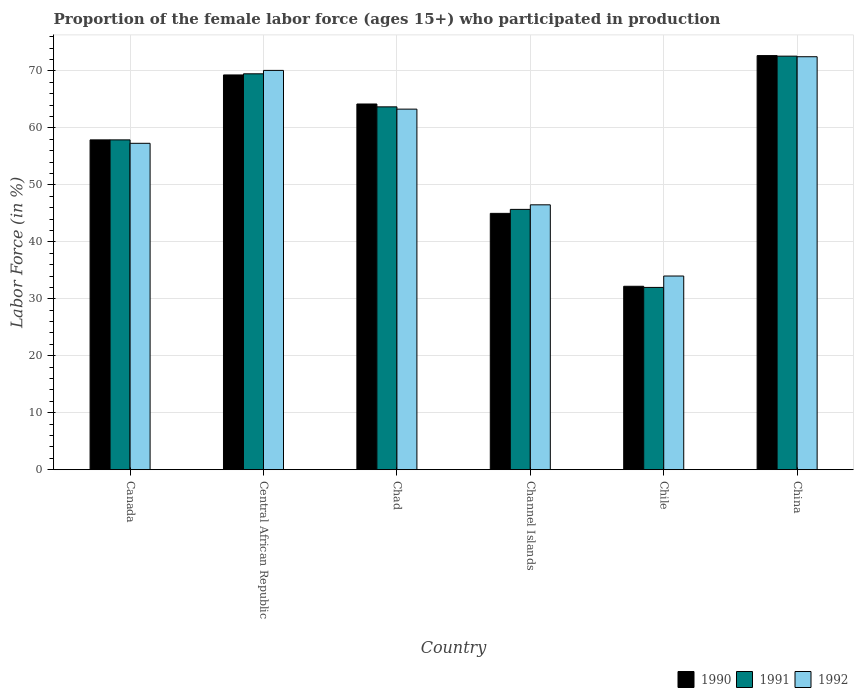How many groups of bars are there?
Ensure brevity in your answer.  6. Are the number of bars per tick equal to the number of legend labels?
Your response must be concise. Yes. Are the number of bars on each tick of the X-axis equal?
Your answer should be very brief. Yes. How many bars are there on the 5th tick from the left?
Offer a very short reply. 3. How many bars are there on the 3rd tick from the right?
Provide a succinct answer. 3. In how many cases, is the number of bars for a given country not equal to the number of legend labels?
Give a very brief answer. 0. What is the proportion of the female labor force who participated in production in 1992 in Channel Islands?
Provide a succinct answer. 46.5. Across all countries, what is the maximum proportion of the female labor force who participated in production in 1992?
Your answer should be compact. 72.5. Across all countries, what is the minimum proportion of the female labor force who participated in production in 1990?
Give a very brief answer. 32.2. In which country was the proportion of the female labor force who participated in production in 1990 maximum?
Offer a very short reply. China. In which country was the proportion of the female labor force who participated in production in 1990 minimum?
Your response must be concise. Chile. What is the total proportion of the female labor force who participated in production in 1992 in the graph?
Provide a succinct answer. 343.7. What is the difference between the proportion of the female labor force who participated in production in 1992 in Canada and that in Chad?
Offer a very short reply. -6. What is the difference between the proportion of the female labor force who participated in production in 1990 in Canada and the proportion of the female labor force who participated in production in 1991 in Channel Islands?
Make the answer very short. 12.2. What is the average proportion of the female labor force who participated in production in 1992 per country?
Provide a short and direct response. 57.28. What is the difference between the proportion of the female labor force who participated in production of/in 1991 and proportion of the female labor force who participated in production of/in 1992 in Channel Islands?
Offer a terse response. -0.8. What is the ratio of the proportion of the female labor force who participated in production in 1992 in Canada to that in Chad?
Your response must be concise. 0.91. Is the proportion of the female labor force who participated in production in 1990 in Central African Republic less than that in China?
Make the answer very short. Yes. Is the difference between the proportion of the female labor force who participated in production in 1991 in Channel Islands and Chile greater than the difference between the proportion of the female labor force who participated in production in 1992 in Channel Islands and Chile?
Your answer should be compact. Yes. What is the difference between the highest and the second highest proportion of the female labor force who participated in production in 1992?
Make the answer very short. 2.4. What is the difference between the highest and the lowest proportion of the female labor force who participated in production in 1992?
Provide a succinct answer. 38.5. What does the 1st bar from the left in Chad represents?
Your answer should be compact. 1990. Are all the bars in the graph horizontal?
Make the answer very short. No. How many countries are there in the graph?
Give a very brief answer. 6. Does the graph contain grids?
Offer a very short reply. Yes. Where does the legend appear in the graph?
Offer a terse response. Bottom right. How are the legend labels stacked?
Offer a terse response. Horizontal. What is the title of the graph?
Your answer should be compact. Proportion of the female labor force (ages 15+) who participated in production. Does "1982" appear as one of the legend labels in the graph?
Your answer should be very brief. No. What is the label or title of the X-axis?
Your answer should be very brief. Country. What is the label or title of the Y-axis?
Make the answer very short. Labor Force (in %). What is the Labor Force (in %) of 1990 in Canada?
Make the answer very short. 57.9. What is the Labor Force (in %) of 1991 in Canada?
Give a very brief answer. 57.9. What is the Labor Force (in %) in 1992 in Canada?
Keep it short and to the point. 57.3. What is the Labor Force (in %) of 1990 in Central African Republic?
Your answer should be compact. 69.3. What is the Labor Force (in %) of 1991 in Central African Republic?
Your response must be concise. 69.5. What is the Labor Force (in %) of 1992 in Central African Republic?
Offer a terse response. 70.1. What is the Labor Force (in %) of 1990 in Chad?
Ensure brevity in your answer.  64.2. What is the Labor Force (in %) of 1991 in Chad?
Offer a terse response. 63.7. What is the Labor Force (in %) in 1992 in Chad?
Offer a very short reply. 63.3. What is the Labor Force (in %) in 1991 in Channel Islands?
Keep it short and to the point. 45.7. What is the Labor Force (in %) in 1992 in Channel Islands?
Offer a very short reply. 46.5. What is the Labor Force (in %) of 1990 in Chile?
Offer a terse response. 32.2. What is the Labor Force (in %) of 1990 in China?
Offer a terse response. 72.7. What is the Labor Force (in %) in 1991 in China?
Offer a very short reply. 72.6. What is the Labor Force (in %) of 1992 in China?
Provide a short and direct response. 72.5. Across all countries, what is the maximum Labor Force (in %) in 1990?
Give a very brief answer. 72.7. Across all countries, what is the maximum Labor Force (in %) in 1991?
Provide a succinct answer. 72.6. Across all countries, what is the maximum Labor Force (in %) of 1992?
Offer a very short reply. 72.5. Across all countries, what is the minimum Labor Force (in %) in 1990?
Give a very brief answer. 32.2. Across all countries, what is the minimum Labor Force (in %) in 1991?
Keep it short and to the point. 32. Across all countries, what is the minimum Labor Force (in %) of 1992?
Your response must be concise. 34. What is the total Labor Force (in %) of 1990 in the graph?
Offer a terse response. 341.3. What is the total Labor Force (in %) in 1991 in the graph?
Give a very brief answer. 341.4. What is the total Labor Force (in %) of 1992 in the graph?
Provide a short and direct response. 343.7. What is the difference between the Labor Force (in %) of 1991 in Canada and that in Central African Republic?
Provide a short and direct response. -11.6. What is the difference between the Labor Force (in %) in 1991 in Canada and that in Channel Islands?
Offer a very short reply. 12.2. What is the difference between the Labor Force (in %) in 1990 in Canada and that in Chile?
Your response must be concise. 25.7. What is the difference between the Labor Force (in %) of 1991 in Canada and that in Chile?
Your answer should be very brief. 25.9. What is the difference between the Labor Force (in %) in 1992 in Canada and that in Chile?
Your answer should be compact. 23.3. What is the difference between the Labor Force (in %) of 1990 in Canada and that in China?
Ensure brevity in your answer.  -14.8. What is the difference between the Labor Force (in %) in 1991 in Canada and that in China?
Keep it short and to the point. -14.7. What is the difference between the Labor Force (in %) of 1992 in Canada and that in China?
Provide a succinct answer. -15.2. What is the difference between the Labor Force (in %) of 1990 in Central African Republic and that in Chad?
Provide a short and direct response. 5.1. What is the difference between the Labor Force (in %) in 1992 in Central African Republic and that in Chad?
Keep it short and to the point. 6.8. What is the difference between the Labor Force (in %) of 1990 in Central African Republic and that in Channel Islands?
Make the answer very short. 24.3. What is the difference between the Labor Force (in %) in 1991 in Central African Republic and that in Channel Islands?
Your response must be concise. 23.8. What is the difference between the Labor Force (in %) of 1992 in Central African Republic and that in Channel Islands?
Your answer should be very brief. 23.6. What is the difference between the Labor Force (in %) in 1990 in Central African Republic and that in Chile?
Give a very brief answer. 37.1. What is the difference between the Labor Force (in %) of 1991 in Central African Republic and that in Chile?
Your response must be concise. 37.5. What is the difference between the Labor Force (in %) in 1992 in Central African Republic and that in Chile?
Make the answer very short. 36.1. What is the difference between the Labor Force (in %) in 1991 in Central African Republic and that in China?
Give a very brief answer. -3.1. What is the difference between the Labor Force (in %) of 1991 in Chad and that in Channel Islands?
Your answer should be very brief. 18. What is the difference between the Labor Force (in %) in 1992 in Chad and that in Channel Islands?
Provide a short and direct response. 16.8. What is the difference between the Labor Force (in %) in 1990 in Chad and that in Chile?
Your response must be concise. 32. What is the difference between the Labor Force (in %) in 1991 in Chad and that in Chile?
Give a very brief answer. 31.7. What is the difference between the Labor Force (in %) in 1992 in Chad and that in Chile?
Offer a very short reply. 29.3. What is the difference between the Labor Force (in %) of 1992 in Chad and that in China?
Give a very brief answer. -9.2. What is the difference between the Labor Force (in %) in 1991 in Channel Islands and that in Chile?
Keep it short and to the point. 13.7. What is the difference between the Labor Force (in %) of 1990 in Channel Islands and that in China?
Give a very brief answer. -27.7. What is the difference between the Labor Force (in %) of 1991 in Channel Islands and that in China?
Give a very brief answer. -26.9. What is the difference between the Labor Force (in %) of 1992 in Channel Islands and that in China?
Keep it short and to the point. -26. What is the difference between the Labor Force (in %) in 1990 in Chile and that in China?
Your answer should be very brief. -40.5. What is the difference between the Labor Force (in %) in 1991 in Chile and that in China?
Offer a very short reply. -40.6. What is the difference between the Labor Force (in %) of 1992 in Chile and that in China?
Your answer should be very brief. -38.5. What is the difference between the Labor Force (in %) of 1990 in Canada and the Labor Force (in %) of 1992 in Central African Republic?
Provide a succinct answer. -12.2. What is the difference between the Labor Force (in %) in 1990 in Canada and the Labor Force (in %) in 1991 in Chad?
Make the answer very short. -5.8. What is the difference between the Labor Force (in %) of 1990 in Canada and the Labor Force (in %) of 1992 in Channel Islands?
Keep it short and to the point. 11.4. What is the difference between the Labor Force (in %) of 1991 in Canada and the Labor Force (in %) of 1992 in Channel Islands?
Offer a terse response. 11.4. What is the difference between the Labor Force (in %) of 1990 in Canada and the Labor Force (in %) of 1991 in Chile?
Your response must be concise. 25.9. What is the difference between the Labor Force (in %) in 1990 in Canada and the Labor Force (in %) in 1992 in Chile?
Provide a short and direct response. 23.9. What is the difference between the Labor Force (in %) in 1991 in Canada and the Labor Force (in %) in 1992 in Chile?
Your response must be concise. 23.9. What is the difference between the Labor Force (in %) of 1990 in Canada and the Labor Force (in %) of 1991 in China?
Provide a succinct answer. -14.7. What is the difference between the Labor Force (in %) of 1990 in Canada and the Labor Force (in %) of 1992 in China?
Your response must be concise. -14.6. What is the difference between the Labor Force (in %) in 1991 in Canada and the Labor Force (in %) in 1992 in China?
Offer a terse response. -14.6. What is the difference between the Labor Force (in %) in 1990 in Central African Republic and the Labor Force (in %) in 1991 in Chad?
Give a very brief answer. 5.6. What is the difference between the Labor Force (in %) of 1991 in Central African Republic and the Labor Force (in %) of 1992 in Chad?
Provide a succinct answer. 6.2. What is the difference between the Labor Force (in %) in 1990 in Central African Republic and the Labor Force (in %) in 1991 in Channel Islands?
Keep it short and to the point. 23.6. What is the difference between the Labor Force (in %) of 1990 in Central African Republic and the Labor Force (in %) of 1992 in Channel Islands?
Provide a short and direct response. 22.8. What is the difference between the Labor Force (in %) of 1990 in Central African Republic and the Labor Force (in %) of 1991 in Chile?
Your answer should be compact. 37.3. What is the difference between the Labor Force (in %) of 1990 in Central African Republic and the Labor Force (in %) of 1992 in Chile?
Ensure brevity in your answer.  35.3. What is the difference between the Labor Force (in %) in 1991 in Central African Republic and the Labor Force (in %) in 1992 in Chile?
Your response must be concise. 35.5. What is the difference between the Labor Force (in %) of 1990 in Central African Republic and the Labor Force (in %) of 1991 in China?
Give a very brief answer. -3.3. What is the difference between the Labor Force (in %) in 1990 in Central African Republic and the Labor Force (in %) in 1992 in China?
Provide a short and direct response. -3.2. What is the difference between the Labor Force (in %) of 1991 in Central African Republic and the Labor Force (in %) of 1992 in China?
Your response must be concise. -3. What is the difference between the Labor Force (in %) of 1990 in Chad and the Labor Force (in %) of 1991 in Chile?
Provide a succinct answer. 32.2. What is the difference between the Labor Force (in %) of 1990 in Chad and the Labor Force (in %) of 1992 in Chile?
Ensure brevity in your answer.  30.2. What is the difference between the Labor Force (in %) of 1991 in Chad and the Labor Force (in %) of 1992 in Chile?
Make the answer very short. 29.7. What is the difference between the Labor Force (in %) in 1990 in Channel Islands and the Labor Force (in %) in 1991 in Chile?
Your answer should be very brief. 13. What is the difference between the Labor Force (in %) in 1991 in Channel Islands and the Labor Force (in %) in 1992 in Chile?
Make the answer very short. 11.7. What is the difference between the Labor Force (in %) of 1990 in Channel Islands and the Labor Force (in %) of 1991 in China?
Your answer should be compact. -27.6. What is the difference between the Labor Force (in %) of 1990 in Channel Islands and the Labor Force (in %) of 1992 in China?
Ensure brevity in your answer.  -27.5. What is the difference between the Labor Force (in %) in 1991 in Channel Islands and the Labor Force (in %) in 1992 in China?
Give a very brief answer. -26.8. What is the difference between the Labor Force (in %) of 1990 in Chile and the Labor Force (in %) of 1991 in China?
Keep it short and to the point. -40.4. What is the difference between the Labor Force (in %) in 1990 in Chile and the Labor Force (in %) in 1992 in China?
Ensure brevity in your answer.  -40.3. What is the difference between the Labor Force (in %) in 1991 in Chile and the Labor Force (in %) in 1992 in China?
Offer a terse response. -40.5. What is the average Labor Force (in %) of 1990 per country?
Provide a short and direct response. 56.88. What is the average Labor Force (in %) in 1991 per country?
Make the answer very short. 56.9. What is the average Labor Force (in %) of 1992 per country?
Keep it short and to the point. 57.28. What is the difference between the Labor Force (in %) of 1990 and Labor Force (in %) of 1991 in Central African Republic?
Keep it short and to the point. -0.2. What is the difference between the Labor Force (in %) of 1991 and Labor Force (in %) of 1992 in Central African Republic?
Provide a succinct answer. -0.6. What is the difference between the Labor Force (in %) in 1990 and Labor Force (in %) in 1992 in Chad?
Give a very brief answer. 0.9. What is the difference between the Labor Force (in %) in 1991 and Labor Force (in %) in 1992 in Chad?
Offer a terse response. 0.4. What is the difference between the Labor Force (in %) of 1990 and Labor Force (in %) of 1992 in Channel Islands?
Your answer should be compact. -1.5. What is the difference between the Labor Force (in %) in 1990 and Labor Force (in %) in 1991 in Chile?
Your answer should be very brief. 0.2. What is the difference between the Labor Force (in %) of 1990 and Labor Force (in %) of 1992 in Chile?
Make the answer very short. -1.8. What is the difference between the Labor Force (in %) in 1991 and Labor Force (in %) in 1992 in Chile?
Ensure brevity in your answer.  -2. What is the difference between the Labor Force (in %) of 1990 and Labor Force (in %) of 1991 in China?
Ensure brevity in your answer.  0.1. What is the ratio of the Labor Force (in %) of 1990 in Canada to that in Central African Republic?
Make the answer very short. 0.84. What is the ratio of the Labor Force (in %) in 1991 in Canada to that in Central African Republic?
Ensure brevity in your answer.  0.83. What is the ratio of the Labor Force (in %) of 1992 in Canada to that in Central African Republic?
Ensure brevity in your answer.  0.82. What is the ratio of the Labor Force (in %) of 1990 in Canada to that in Chad?
Your answer should be compact. 0.9. What is the ratio of the Labor Force (in %) in 1991 in Canada to that in Chad?
Provide a succinct answer. 0.91. What is the ratio of the Labor Force (in %) in 1992 in Canada to that in Chad?
Offer a very short reply. 0.91. What is the ratio of the Labor Force (in %) of 1990 in Canada to that in Channel Islands?
Provide a short and direct response. 1.29. What is the ratio of the Labor Force (in %) of 1991 in Canada to that in Channel Islands?
Provide a succinct answer. 1.27. What is the ratio of the Labor Force (in %) in 1992 in Canada to that in Channel Islands?
Make the answer very short. 1.23. What is the ratio of the Labor Force (in %) of 1990 in Canada to that in Chile?
Offer a terse response. 1.8. What is the ratio of the Labor Force (in %) in 1991 in Canada to that in Chile?
Offer a very short reply. 1.81. What is the ratio of the Labor Force (in %) in 1992 in Canada to that in Chile?
Ensure brevity in your answer.  1.69. What is the ratio of the Labor Force (in %) in 1990 in Canada to that in China?
Provide a succinct answer. 0.8. What is the ratio of the Labor Force (in %) in 1991 in Canada to that in China?
Provide a short and direct response. 0.8. What is the ratio of the Labor Force (in %) in 1992 in Canada to that in China?
Make the answer very short. 0.79. What is the ratio of the Labor Force (in %) of 1990 in Central African Republic to that in Chad?
Provide a succinct answer. 1.08. What is the ratio of the Labor Force (in %) in 1991 in Central African Republic to that in Chad?
Make the answer very short. 1.09. What is the ratio of the Labor Force (in %) of 1992 in Central African Republic to that in Chad?
Ensure brevity in your answer.  1.11. What is the ratio of the Labor Force (in %) in 1990 in Central African Republic to that in Channel Islands?
Provide a succinct answer. 1.54. What is the ratio of the Labor Force (in %) of 1991 in Central African Republic to that in Channel Islands?
Offer a very short reply. 1.52. What is the ratio of the Labor Force (in %) in 1992 in Central African Republic to that in Channel Islands?
Provide a short and direct response. 1.51. What is the ratio of the Labor Force (in %) of 1990 in Central African Republic to that in Chile?
Offer a very short reply. 2.15. What is the ratio of the Labor Force (in %) of 1991 in Central African Republic to that in Chile?
Offer a terse response. 2.17. What is the ratio of the Labor Force (in %) of 1992 in Central African Republic to that in Chile?
Your answer should be very brief. 2.06. What is the ratio of the Labor Force (in %) in 1990 in Central African Republic to that in China?
Your response must be concise. 0.95. What is the ratio of the Labor Force (in %) in 1991 in Central African Republic to that in China?
Offer a very short reply. 0.96. What is the ratio of the Labor Force (in %) of 1992 in Central African Republic to that in China?
Ensure brevity in your answer.  0.97. What is the ratio of the Labor Force (in %) of 1990 in Chad to that in Channel Islands?
Provide a short and direct response. 1.43. What is the ratio of the Labor Force (in %) in 1991 in Chad to that in Channel Islands?
Your answer should be compact. 1.39. What is the ratio of the Labor Force (in %) of 1992 in Chad to that in Channel Islands?
Offer a very short reply. 1.36. What is the ratio of the Labor Force (in %) in 1990 in Chad to that in Chile?
Keep it short and to the point. 1.99. What is the ratio of the Labor Force (in %) of 1991 in Chad to that in Chile?
Offer a very short reply. 1.99. What is the ratio of the Labor Force (in %) of 1992 in Chad to that in Chile?
Keep it short and to the point. 1.86. What is the ratio of the Labor Force (in %) in 1990 in Chad to that in China?
Give a very brief answer. 0.88. What is the ratio of the Labor Force (in %) of 1991 in Chad to that in China?
Offer a very short reply. 0.88. What is the ratio of the Labor Force (in %) of 1992 in Chad to that in China?
Provide a succinct answer. 0.87. What is the ratio of the Labor Force (in %) in 1990 in Channel Islands to that in Chile?
Ensure brevity in your answer.  1.4. What is the ratio of the Labor Force (in %) in 1991 in Channel Islands to that in Chile?
Keep it short and to the point. 1.43. What is the ratio of the Labor Force (in %) of 1992 in Channel Islands to that in Chile?
Offer a terse response. 1.37. What is the ratio of the Labor Force (in %) in 1990 in Channel Islands to that in China?
Ensure brevity in your answer.  0.62. What is the ratio of the Labor Force (in %) of 1991 in Channel Islands to that in China?
Provide a succinct answer. 0.63. What is the ratio of the Labor Force (in %) in 1992 in Channel Islands to that in China?
Offer a very short reply. 0.64. What is the ratio of the Labor Force (in %) of 1990 in Chile to that in China?
Make the answer very short. 0.44. What is the ratio of the Labor Force (in %) in 1991 in Chile to that in China?
Make the answer very short. 0.44. What is the ratio of the Labor Force (in %) in 1992 in Chile to that in China?
Provide a succinct answer. 0.47. What is the difference between the highest and the second highest Labor Force (in %) in 1991?
Your response must be concise. 3.1. What is the difference between the highest and the second highest Labor Force (in %) of 1992?
Make the answer very short. 2.4. What is the difference between the highest and the lowest Labor Force (in %) in 1990?
Keep it short and to the point. 40.5. What is the difference between the highest and the lowest Labor Force (in %) of 1991?
Provide a short and direct response. 40.6. What is the difference between the highest and the lowest Labor Force (in %) in 1992?
Your answer should be very brief. 38.5. 